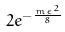<formula> <loc_0><loc_0><loc_500><loc_500>2 e ^ { - \frac { m \epsilon ^ { 2 } } { 8 } }</formula> 